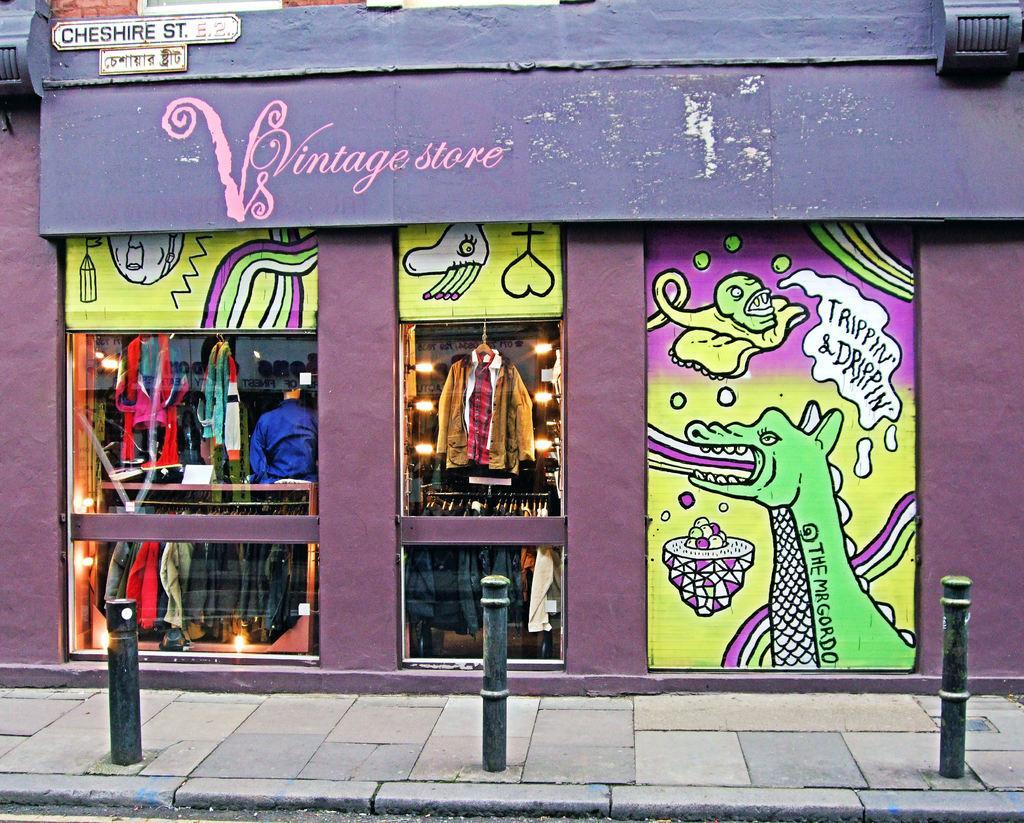How would you summarize this image in a sentence or two? In this image we can see a store. There are many clothes in the store. There are few lights in the image. There are few paintings on the wall in the image. There is some text on the wall. There are few boards in the image. There are few barrier poles in the image. 